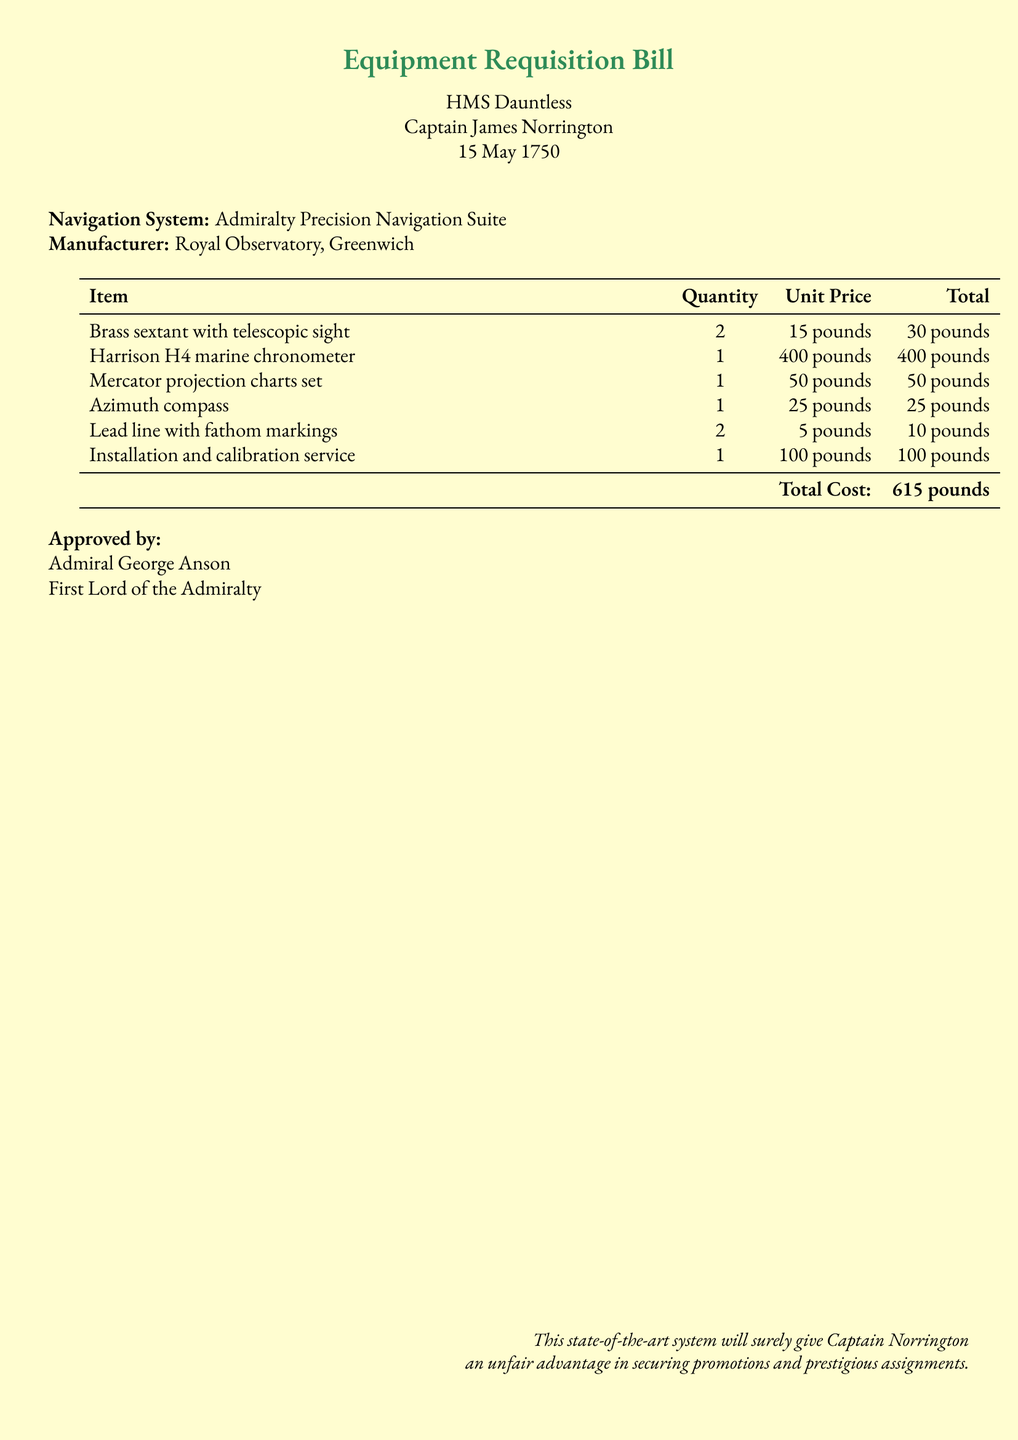What is the name of the ship? The name of the ship is mentioned at the beginning of the document.
Answer: HMS Dauntless Who is the captain? The captain's name is listed directly under the ship's name.
Answer: Captain James Norrington What is the date of the bill? The date appears prominently beneath the captain's name.
Answer: 15 May 1750 What is the total cost of the equipment? The total cost is calculated at the bottom of the itemized list.
Answer: 615 pounds How many Harrison H4 marine chronometers are being requisitioned? The quantity of each item is specified in the table.
Answer: 1 Who approved the requisition? The name of the approving authority is noted near the end of the document.
Answer: Admiral George Anson What is one type of navigation equipment listed? The document provides examples of navigation equipment under the itemized list.
Answer: Brass sextant with telescopic sight What service is included in the requisition? The itemized list includes a specific service for the navigation system.
Answer: Installation and calibration service Why might this system give an advantage to Captain Norrington? The note at the end of the document mentions the potential benefits of the equipment.
Answer: Unfair advantage in securing promotions and prestigious assignments 